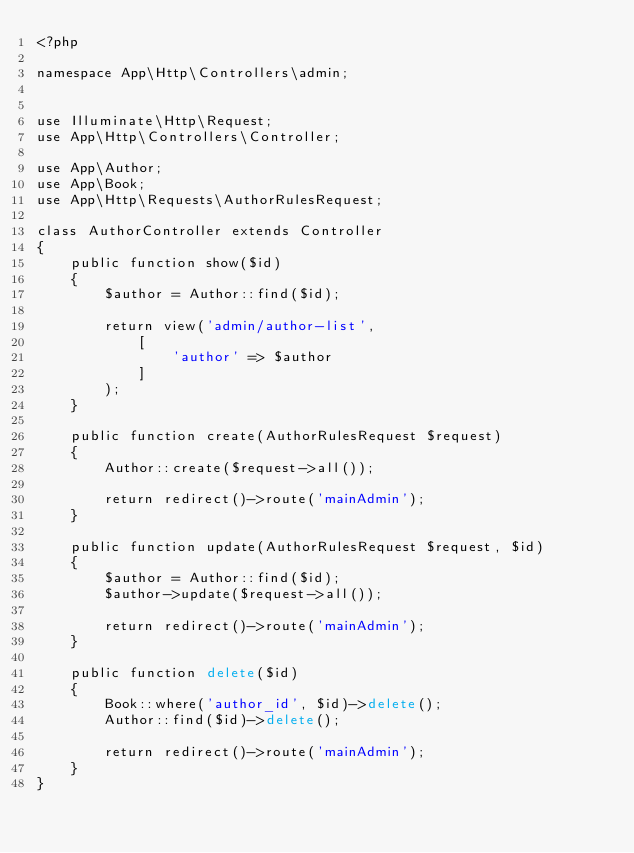Convert code to text. <code><loc_0><loc_0><loc_500><loc_500><_PHP_><?php

namespace App\Http\Controllers\admin;


use Illuminate\Http\Request;
use App\Http\Controllers\Controller;

use App\Author;
use App\Book;
use App\Http\Requests\AuthorRulesRequest;

class AuthorController extends Controller
{
    public function show($id)
    {
        $author = Author::find($id);

        return view('admin/author-list',
            [
                'author' => $author
            ]
        );
    }

    public function create(AuthorRulesRequest $request)
    {
        Author::create($request->all());

        return redirect()->route('mainAdmin');
    }

    public function update(AuthorRulesRequest $request, $id)
    {
        $author = Author::find($id);
        $author->update($request->all());

        return redirect()->route('mainAdmin');
    }

    public function delete($id)
    {
        Book::where('author_id', $id)->delete();
        Author::find($id)->delete();

        return redirect()->route('mainAdmin');
    }
}
</code> 